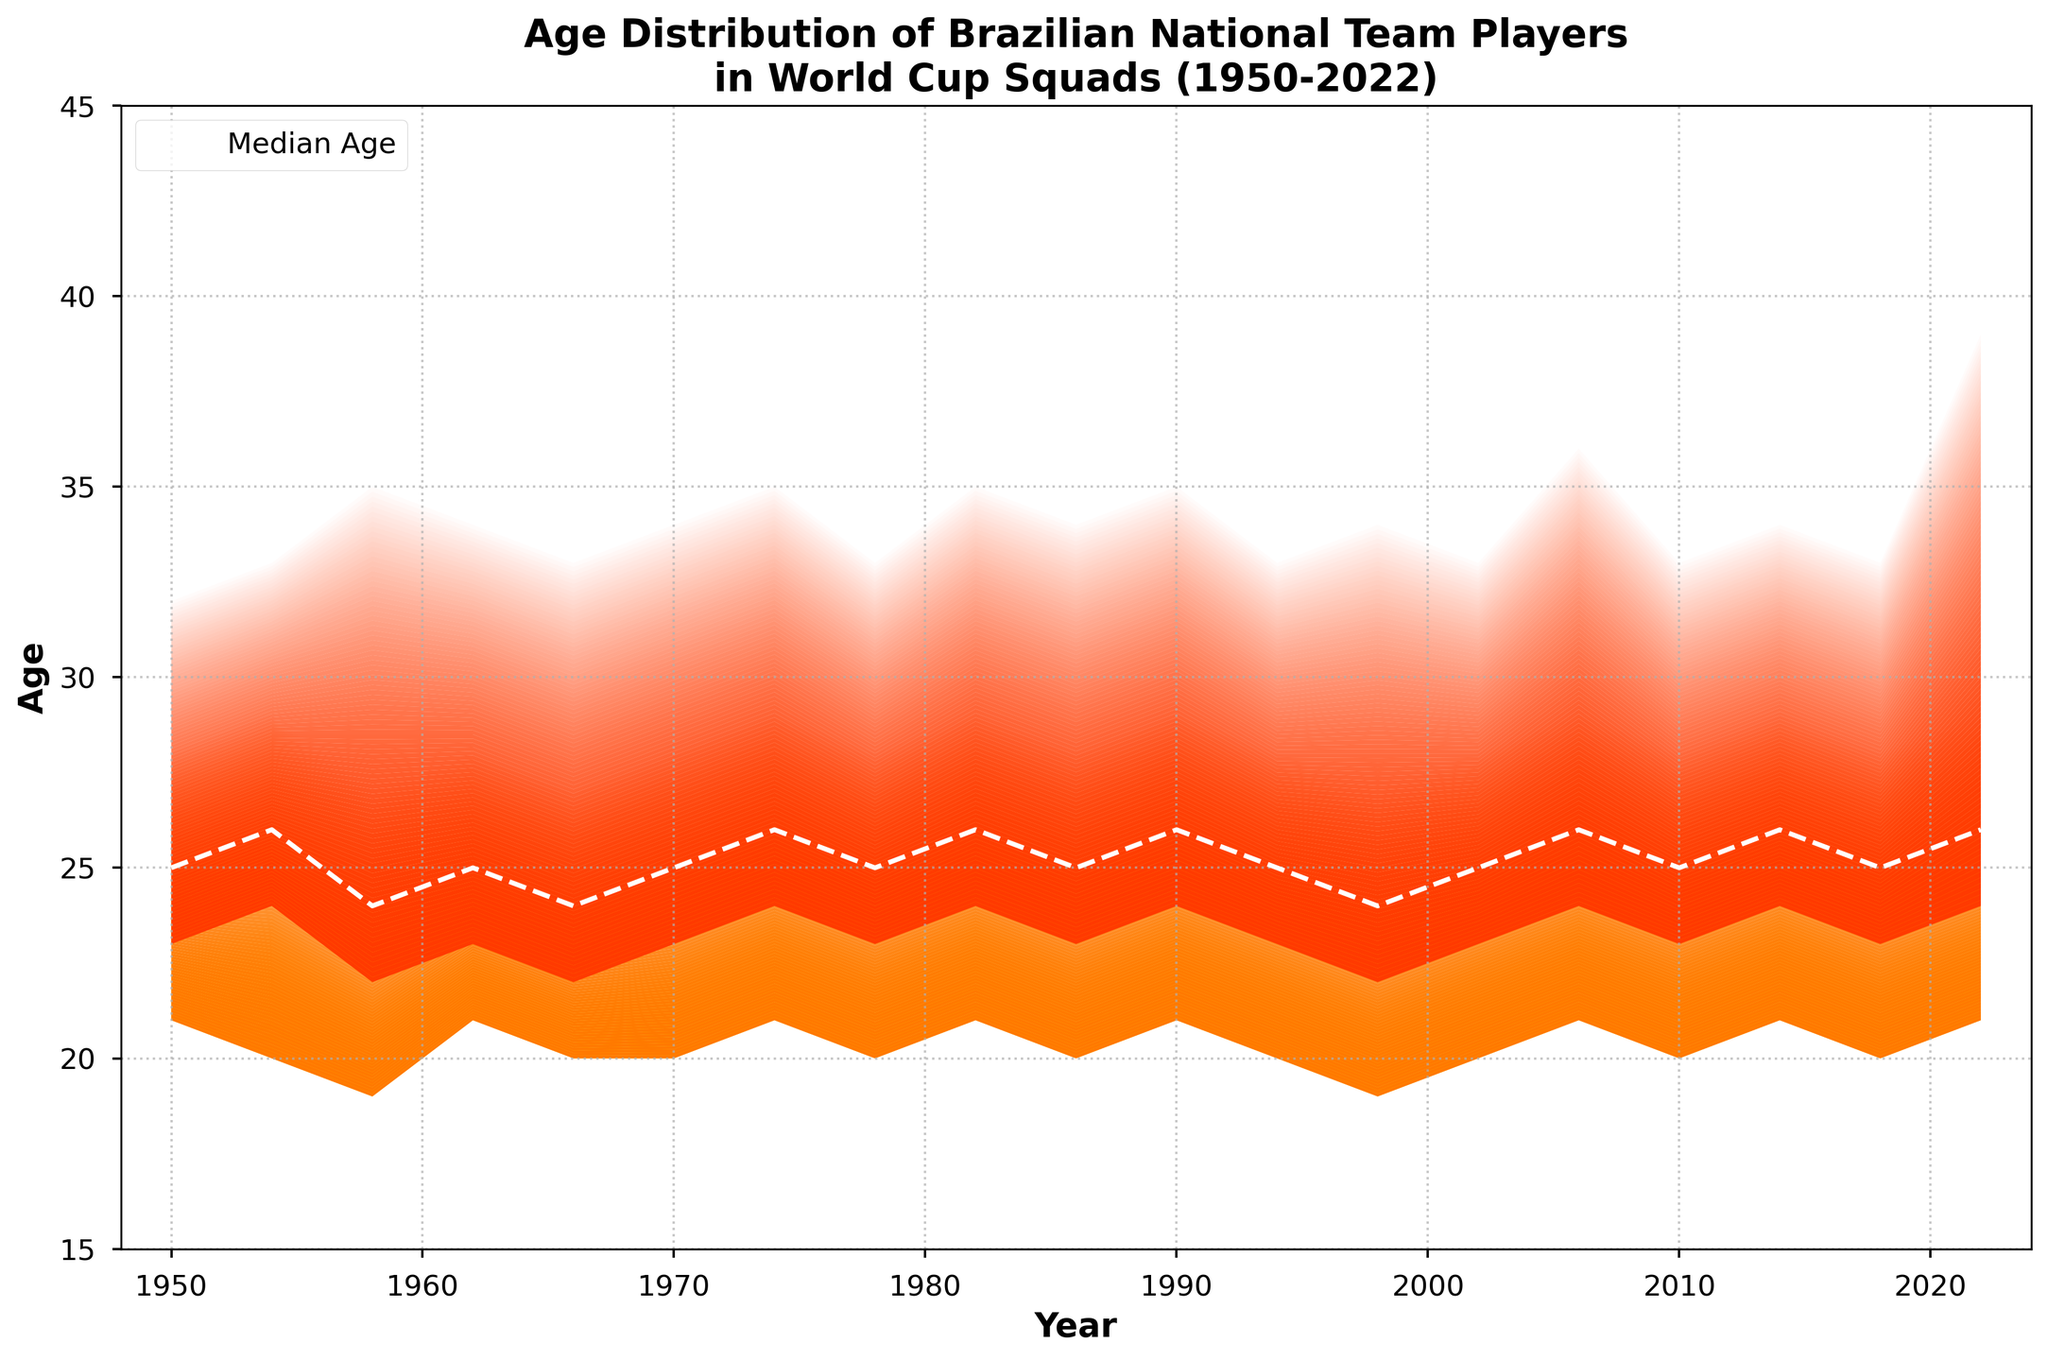What is the title of this fan chart? The title is located at the top of the chart. It reads "Age Distribution of Brazilian National Team Players in World Cup Squads (1950-2022)".
Answer: Age Distribution of Brazilian National Team Players in World Cup Squads (1950-2022) What is the median age of players in the 2022 squad? The median age is represented by the dashed white line in the chart. For the year 2022, trace the dashed line to see that it aligns with an age of 26.
Answer: 26 In which year did the oldest player in the dataset appear, and how old was he? Look at the topmost layer of the fan chart, which represents the maximum age of players. The oldest player is represented by the red area. In 2022, trace the top of the red area to see it reaches 39 years old.
Answer: 2022, 39 years old How does the 1st quartile of player ages in 1958 compare to that in 1974? The 1st quartile age is the line between the yellow and the light orange areas. In 1958, it is 22 years old; in 1974, it is 24 years old. Hence, the 1st quartile age in 1974 is higher by 2 years.
Answer: 1974 is 2 years higher Which year had the youngest minimum age? The minimum age is the bottom edge of the chart. The youngest minimum age appears in 1958, which is 19 years old.
Answer: 1958, 19 years old What's the interquartile range (IQR) in 2014 and how is it compared to the 1994 IQR? The IQR is the difference between the 3rd quartile and the 1st quartile. In 2014, the 3rd quartile is 29 and the 1st quartile is 24, so IQR is 5. In 1994, the 3rd quartile is also 28 and the 1st quartile is 23, so the IQR is also 5.
Answer: Both IQRs are 5 Which year has the highest variability in player ages, and how can you tell? The variability can be seen by the spread between the minimum and maximum ages. In 2022, the minimum age is 21 and the maximum is 39, giving a range of 18 years, which is the highest variability.
Answer: 2022 How did the median age of players change from 1954 to 1962? Track the dashed white line from 1954 to 1962. In 1954, the median age is 26; in 1962, it is 25. Thus, the median age decreased by 1 year.
Answer: Decreased by 1 year What trend can you observe in the maximum age of players between 1950 and 2022? Look at the topmost boundary of the red area. Starting from 32 in 1950, it fluctuates but generally increases over the years, reaching as high as 39 in 2022.
Answer: Increasing trend What's the average age of the oldest players in the squads for the years 2006, 2010, 2014, and 2018? Add the maximum ages for 2006 (36), 2010 (33), 2014 (34), and 2018 (33). Sum = 36 + 33 + 34 + 33 = 136. The average = 136 / 4 = 34.
Answer: 34 